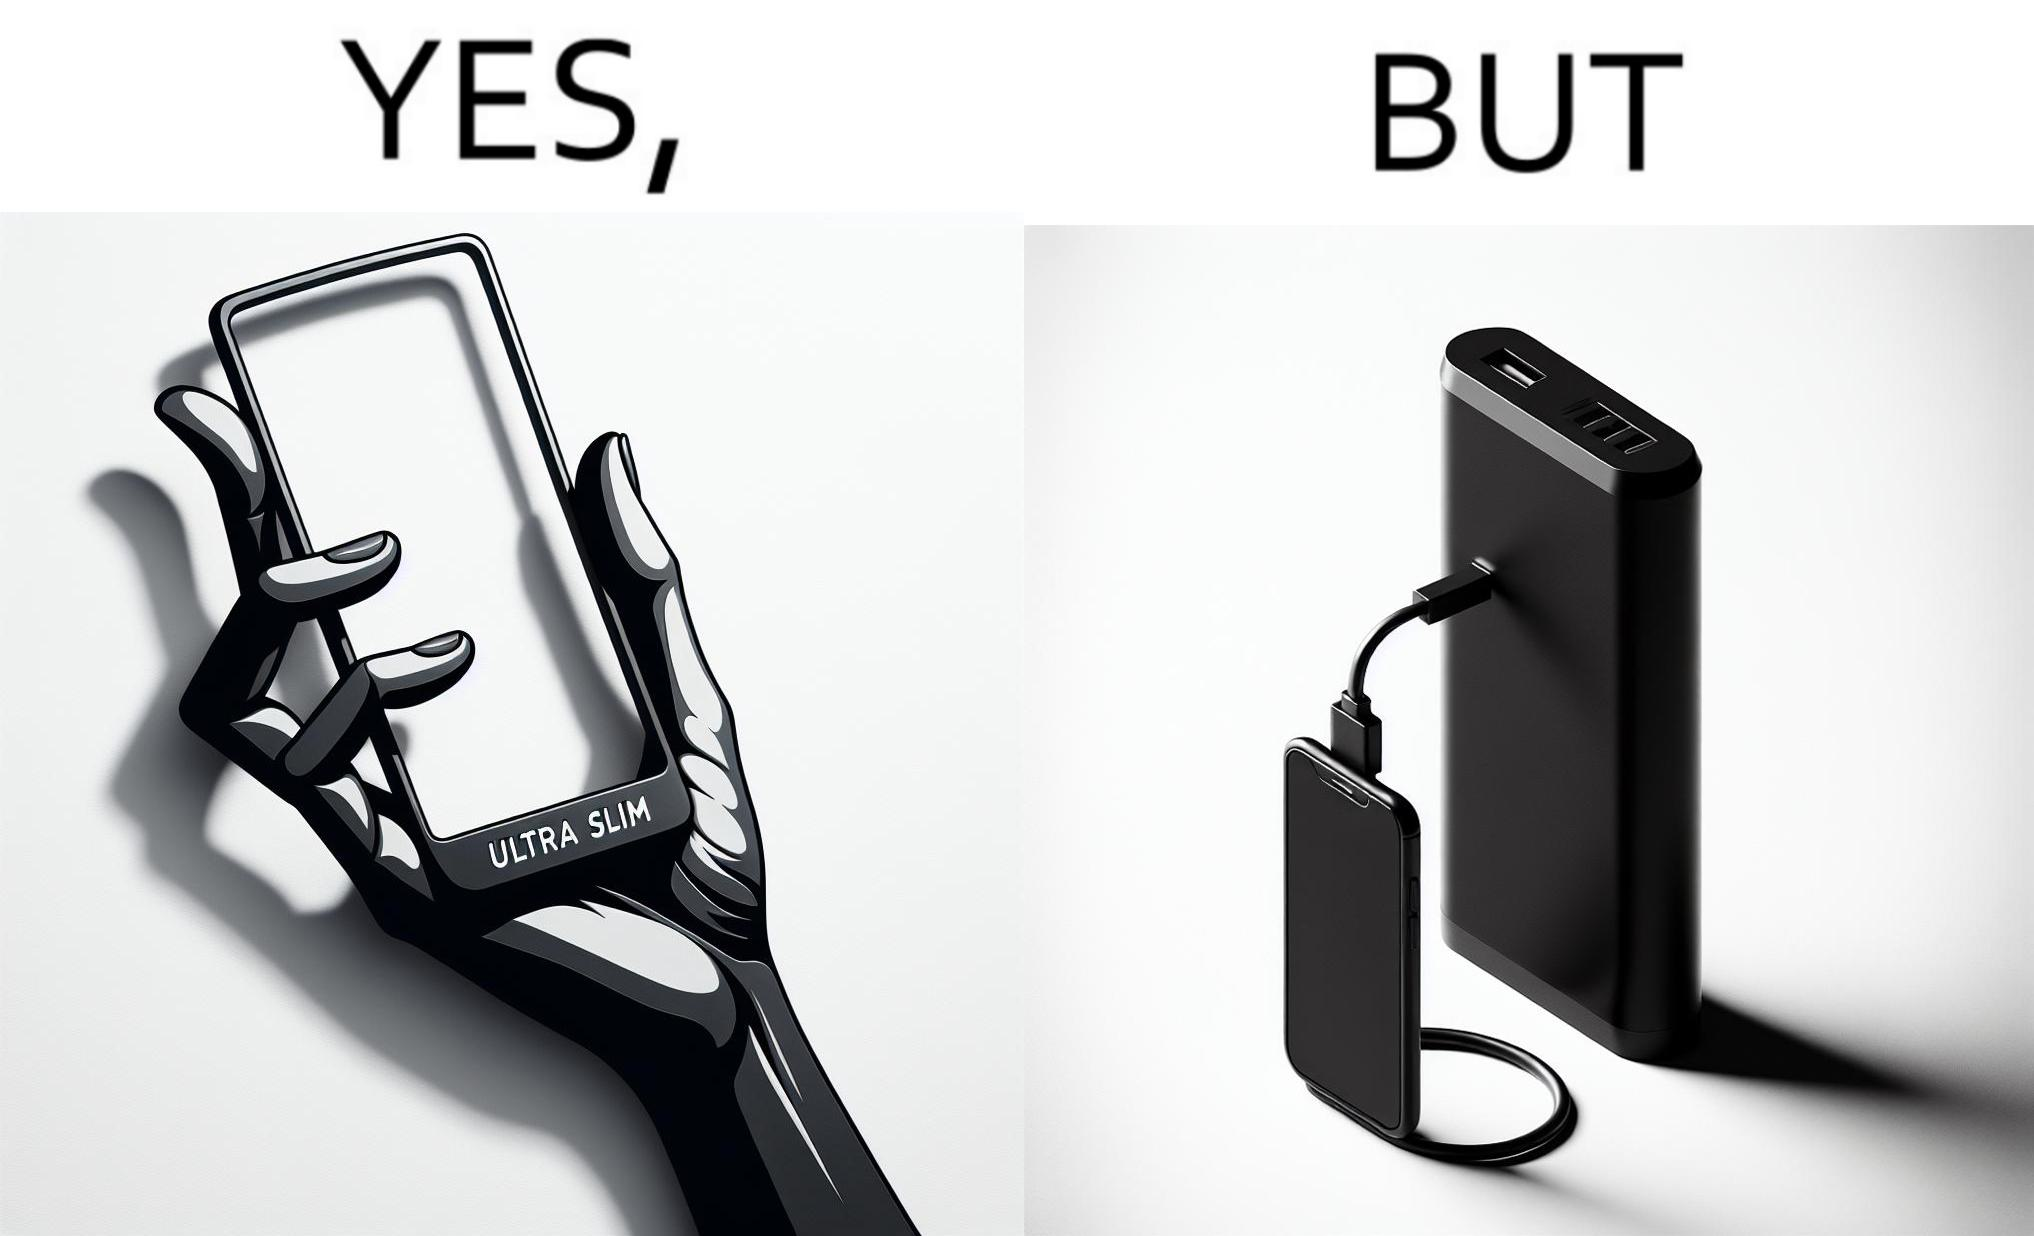Describe the satirical element in this image. The image is satirical because even though the mobile phone has been developed to be very slim, it requires frequent recharging which makes the mobile phone useless without a big, heavy and thick power bank. 